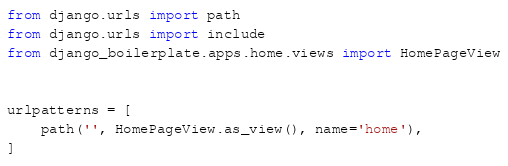Convert code to text. <code><loc_0><loc_0><loc_500><loc_500><_Python_>from django.urls import path
from django.urls import include
from django_boilerplate.apps.home.views import HomePageView


urlpatterns = [
    path('', HomePageView.as_view(), name='home'),
]

</code> 